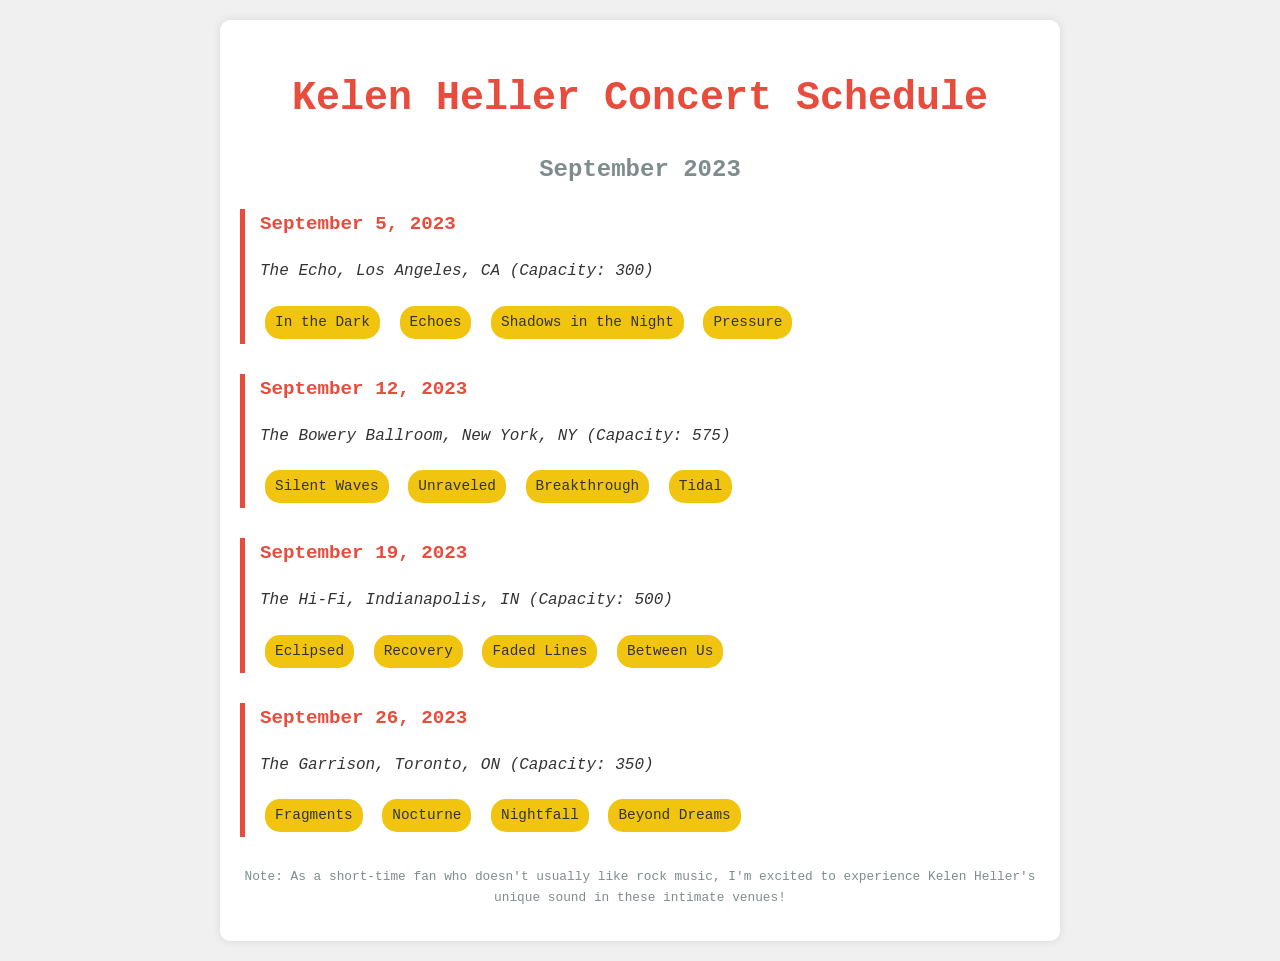What is the first concert date? The first concert date mentioned in the document is September 5, 2023.
Answer: September 5, 2023 What is the venue for the September 12 concert? The venue for the September 12 concert is The Bowery Ballroom in New York, NY.
Answer: The Bowery Ballroom How many songs are in the setlist for the concert on September 19? The setlist for the September 19 concert includes four songs.
Answer: Four What is the capacity of The Echo venue? The capacity of The Echo venue is 300.
Answer: 300 Which song is performed at the concert on September 26? The song "Fragments" is performed at the concert on September 26.
Answer: Fragments Which city hosts the concert on September 5? The concert on September 5 is hosted in Los Angeles, CA.
Answer: Los Angeles, CA How many total concerts are listed for September 2023? There are a total of four concerts listed for September 2023.
Answer: Four Which concert features the song "Recovery"? The concert featuring the song "Recovery" is on September 19 in Indianapolis, IN.
Answer: September 19 What color is used for the concert schedule title in the document? The color used for the concert schedule title is red (#e74c3c).
Answer: Red 